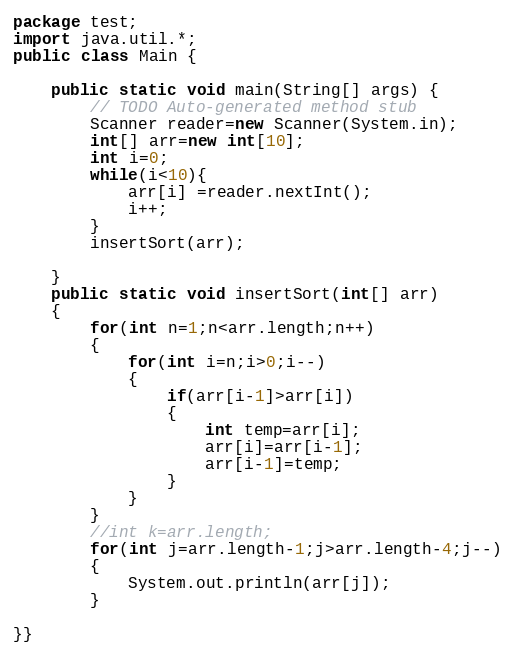Convert code to text. <code><loc_0><loc_0><loc_500><loc_500><_Java_>package test;
import java.util.*;
public class Main {

	public static void main(String[] args) {
		// TODO Auto-generated method stub
		Scanner reader=new Scanner(System.in);
		int[] arr=new int[10];
		int i=0;
		while(i<10){
		    arr[i] =reader.nextInt();
		    i++;
		}
		insertSort(arr);
		
	}
	public static void insertSort(int[] arr)
	{
		for(int n=1;n<arr.length;n++)
		{
			for(int i=n;i>0;i--)
			{
				if(arr[i-1]>arr[i])
				{
					int temp=arr[i];
					arr[i]=arr[i-1];
					arr[i-1]=temp;
				}
			}
		}
		//int k=arr.length;
		for(int j=arr.length-1;j>arr.length-4;j--)
		{
			System.out.println(arr[j]);
		}

}}</code> 